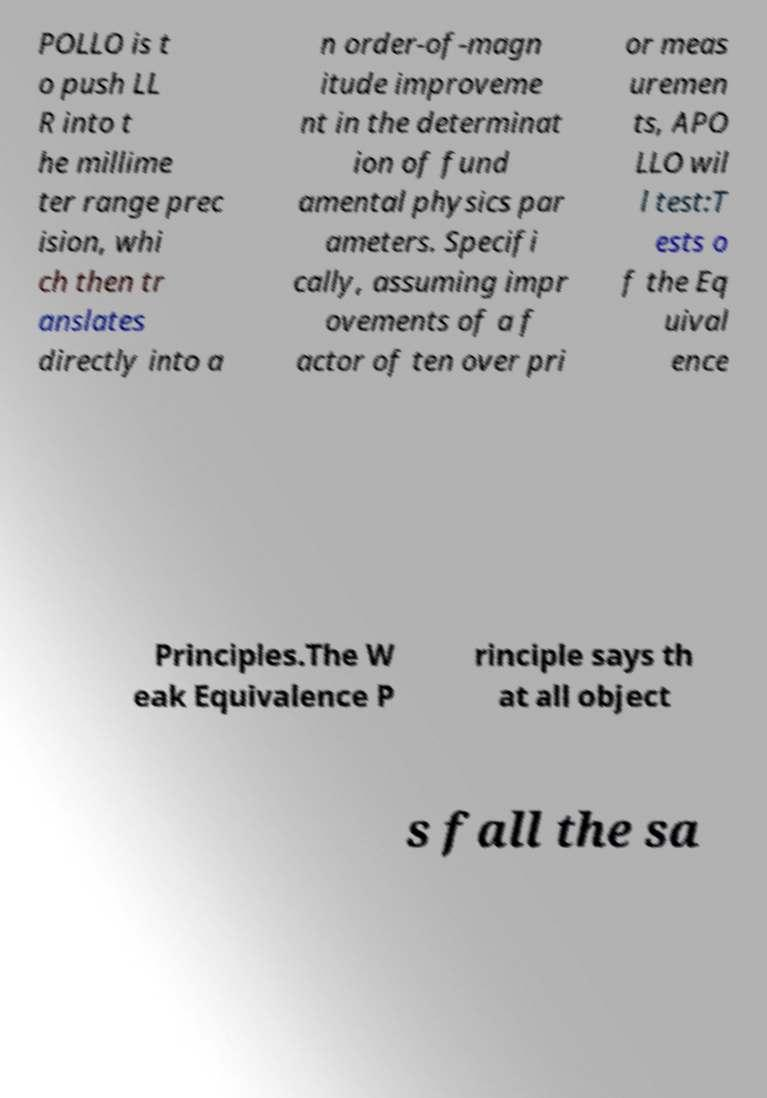What messages or text are displayed in this image? I need them in a readable, typed format. POLLO is t o push LL R into t he millime ter range prec ision, whi ch then tr anslates directly into a n order-of-magn itude improveme nt in the determinat ion of fund amental physics par ameters. Specifi cally, assuming impr ovements of a f actor of ten over pri or meas uremen ts, APO LLO wil l test:T ests o f the Eq uival ence Principles.The W eak Equivalence P rinciple says th at all object s fall the sa 